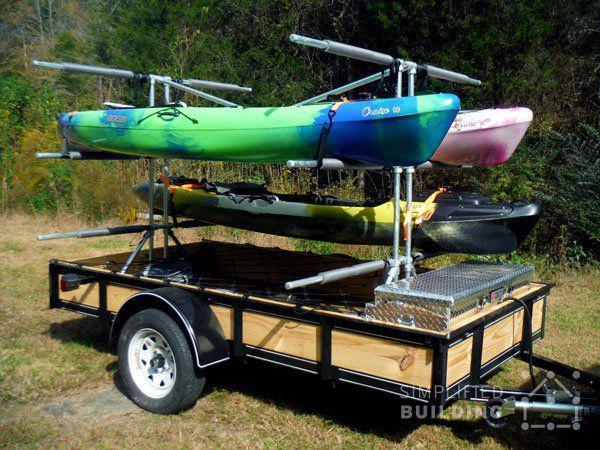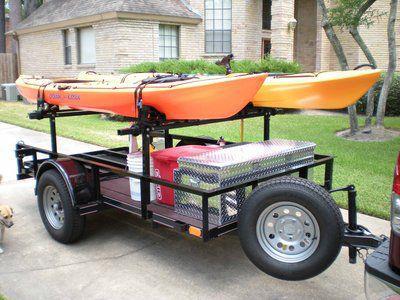The first image is the image on the left, the second image is the image on the right. Evaluate the accuracy of this statement regarding the images: "An image shows two orange boats atop a trailer.". Is it true? Answer yes or no. Yes. The first image is the image on the left, the second image is the image on the right. For the images shown, is this caption "There are at least five canoes in the image on the left." true? Answer yes or no. No. 